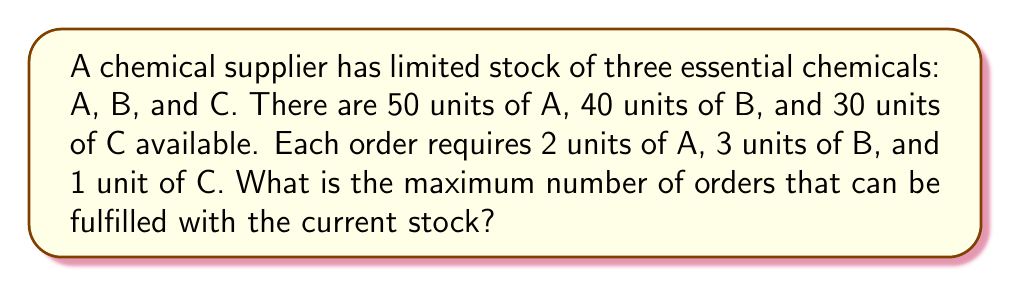Can you solve this math problem? To solve this problem, we need to determine which chemical will be the limiting factor in fulfilling orders. Let's calculate how many orders can be fulfilled based on each chemical:

1. For chemical A:
   $$ \text{Orders}_A = \left\lfloor\frac{50 \text{ units}}{2 \text{ units per order}}\right\rfloor = 25 \text{ orders} $$

2. For chemical B:
   $$ \text{Orders}_B = \left\lfloor\frac{40 \text{ units}}{3 \text{ units per order}}\right\rfloor = 13 \text{ orders} $$

3. For chemical C:
   $$ \text{Orders}_C = \left\lfloor\frac{30 \text{ units}}{1 \text{ unit per order}}\right\rfloor = 30 \text{ orders} $$

The maximum number of orders that can be fulfilled is limited by the chemical with the lowest number of possible orders. In this case, it's chemical B, which allows for only 13 orders.

Verification:
- 13 orders require $13 \times 2 = 26$ units of A (available: 50)
- 13 orders require $13 \times 3 = 39$ units of B (available: 40)
- 13 orders require $13 \times 1 = 13$ units of C (available: 30)

Therefore, the maximum number of orders that can be fulfilled is 13.
Answer: 13 orders 